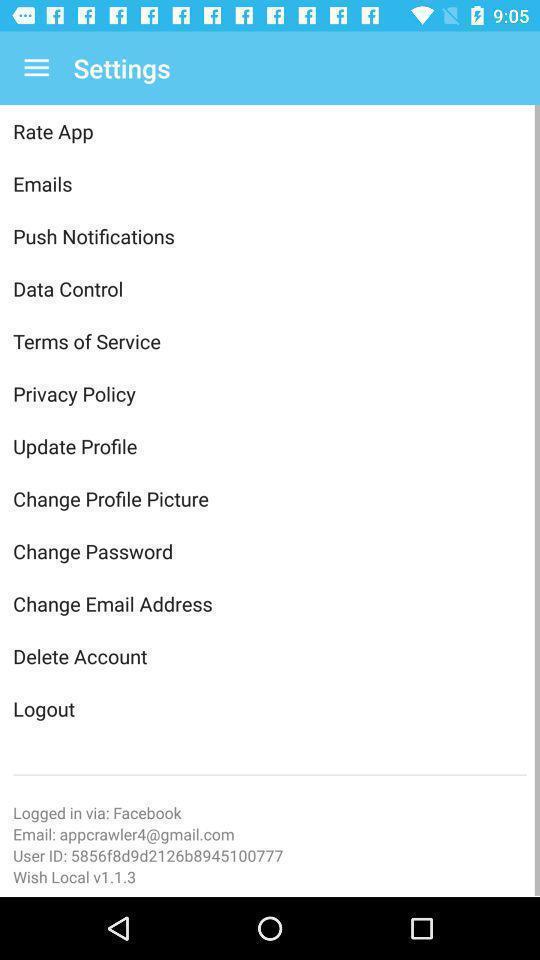Tell me what you see in this picture. Settings page displayed. 